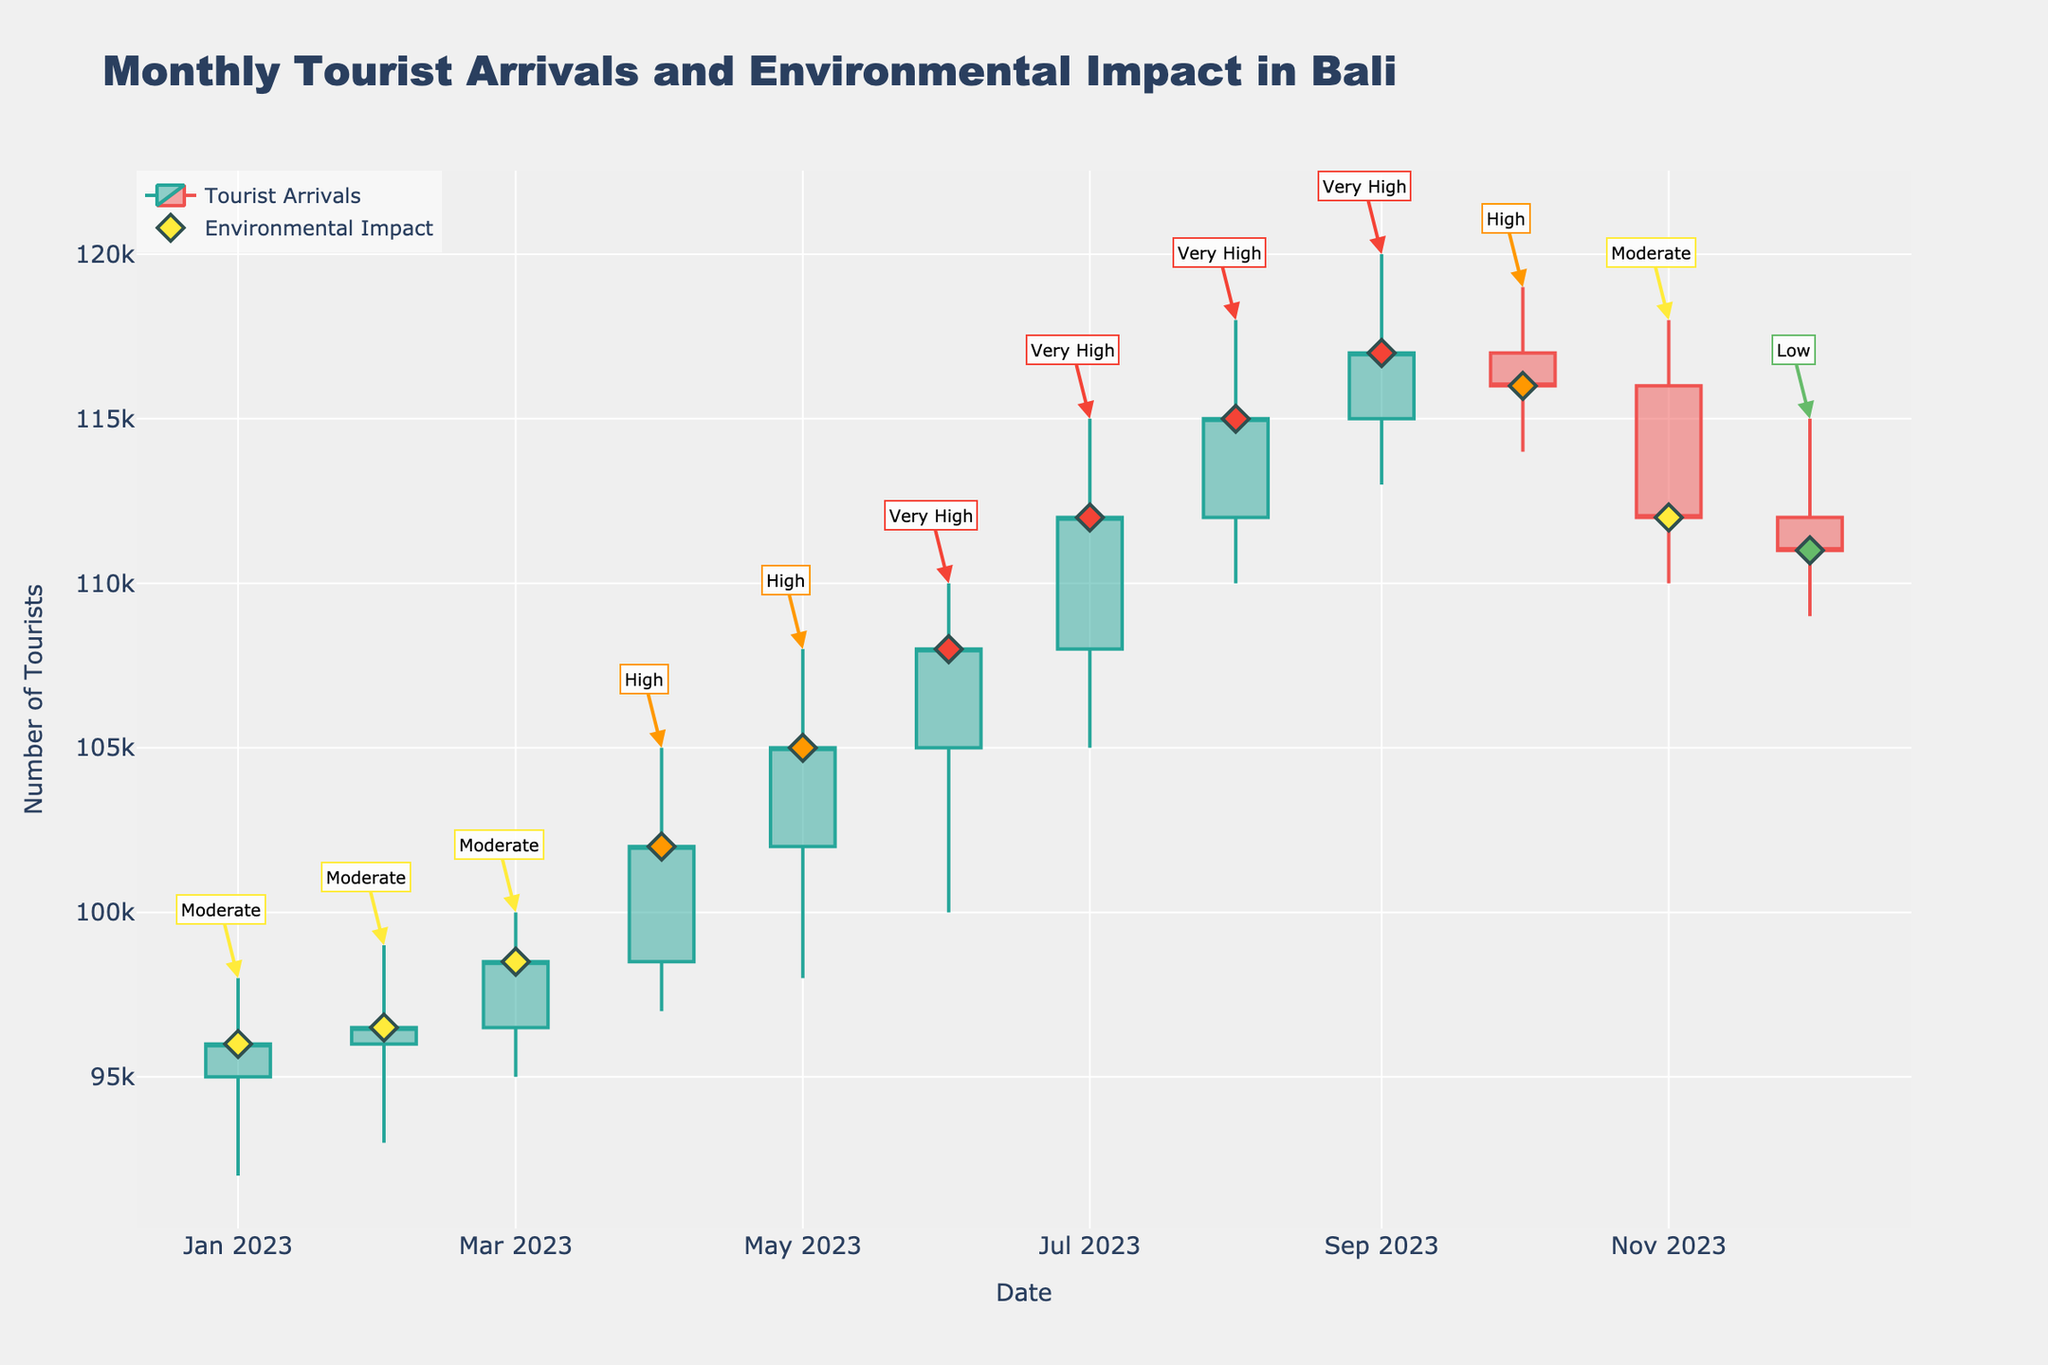What is the title of the plot? The title is located at the top of the plot and gives an overview of what the data represents.
Answer: Monthly Tourist Arrivals and Environmental Impact in Bali Which month had the highest number of tourist arrivals? The highest number of tourist arrivals is indicated by the highest "High" value on the candlestick. Locate the month with the highest peak.
Answer: September 2023 How did the number of tourist arrivals change from January to December 2023? Compare the "Open" value of January with the "Close" value of December to see the overall change. January opens at 95,000, and December closes at 111,000.
Answer: Increased by 16,000 What was the environmental impact in August 2023? Look for the color-coded diamond marker for August 2023 and check its annotation, which indicates the environmental impact.
Answer: Very High Compare the number of tourist arrivals between April and October 2023. Which month had higher arrivals? Compare the "Close" values for April and October. April's "Close" value is 102,000 and October's is 116,000.
Answer: October What is the pattern of environmental impact as the number of tourists increases throughout the year? Examine the color changes of the markers and see how the "Environmental Impact" annotations change with increasing tourist numbers.
Answer: The impact shifted from Moderate to Very High and then back to Low What are the lower and upper limits of tourist arrivals in June 2023? The lower limit is the "Low" value and the upper limit is the "High" value for June. June's "Low" is 100,000 and "High" is 110,000.
Answer: Between 100,000 and 110,000 In which month did we first see a "Very High" environmental impact? Locate the first instance of the red diamond marker and its corresponding month.
Answer: June 2023 Which month had the smallest difference between its "High" and "Low" values? Calculate the difference (High - Low) for each month and find the smallest one.
Answer: December 2023 How does the environmental impact in November 2023 compare to September 2023? Check the color-coded markers and their annotations for both months. November is Moderate, and September is Very High.
Answer: Lower in November 